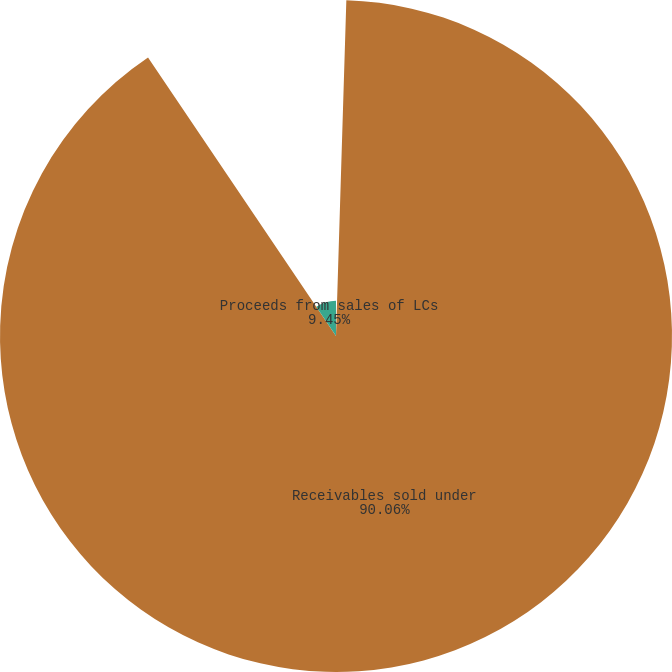Convert chart to OTSL. <chart><loc_0><loc_0><loc_500><loc_500><pie_chart><fcel>(In thousands)<fcel>Receivables sold under<fcel>Proceeds from sales of LCs<nl><fcel>0.49%<fcel>90.06%<fcel>9.45%<nl></chart> 